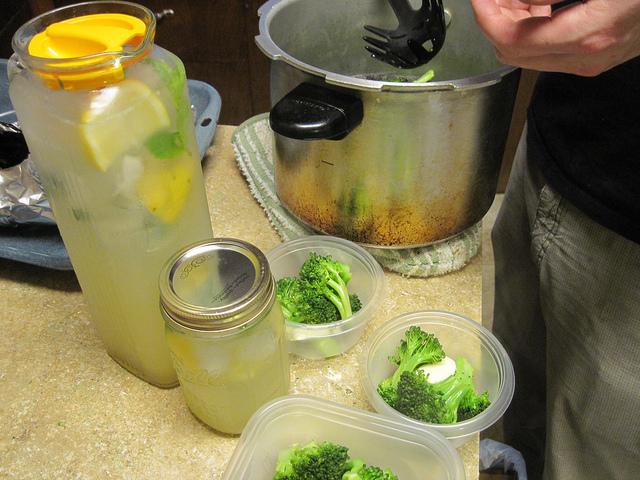What is the veggie in the picture?
Quick response, please. Broccoli. What is the jars filled with?
Keep it brief. Broccoli. What fruit is in the bottle?
Quick response, please. Lemon. What is the green vegetable?
Keep it brief. Broccoli. What is the green stuff in the bowl?
Give a very brief answer. Broccoli. What food item is in the jar on the counter top?
Be succinct. Broccoli. What are the orange chunks in the blender?
Answer briefly. Lemons. What type of fruit is by the cup?
Keep it brief. Lemon. How many cups of broccoli are there?
Keep it brief. 3. 